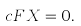Convert formula to latex. <formula><loc_0><loc_0><loc_500><loc_500>& c F X = 0 .</formula> 